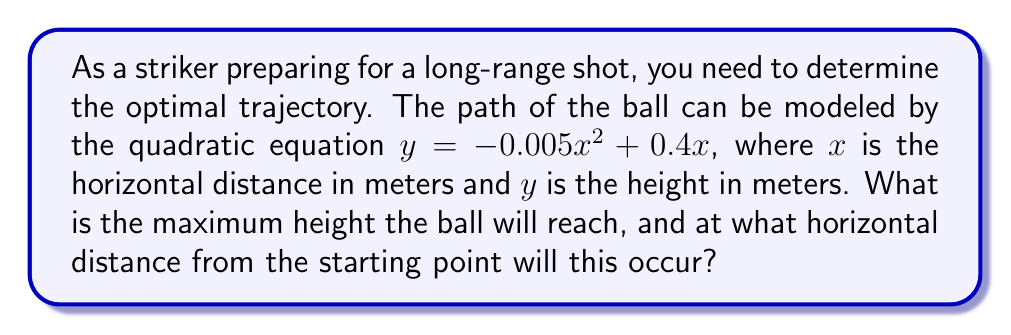Provide a solution to this math problem. To solve this problem, we'll follow these steps:

1) The quadratic equation representing the ball's trajectory is:
   $y = -0.005x^2 + 0.4x$

2) To find the maximum height, we need to find the vertex of this parabola. For a quadratic equation in the form $y = ax^2 + bx + c$, the x-coordinate of the vertex is given by $x = -\frac{b}{2a}$.

3) In our equation, $a = -0.005$ and $b = 0.4$. Let's substitute these values:

   $x = -\frac{0.4}{2(-0.005)} = -\frac{0.4}{-0.01} = 40$

4) This means the ball will reach its maximum height 40 meters from the starting point.

5) To find the maximum height, we substitute $x = 40$ into our original equation:

   $y = -0.005(40)^2 + 0.4(40)$
   $y = -0.005(1600) + 16$
   $y = -8 + 16 = 8$

Therefore, the maximum height the ball will reach is 8 meters.
Answer: Maximum height: 8 meters; occurs 40 meters from starting point 